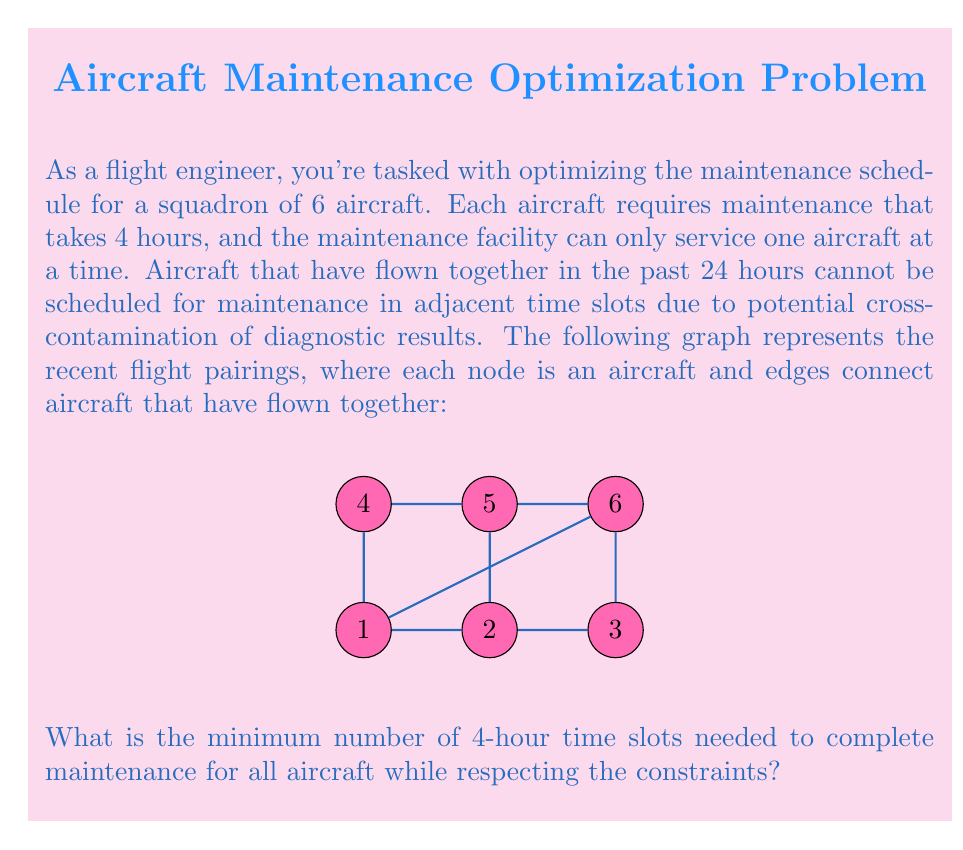Can you solve this math problem? To solve this problem, we can use graph coloring:

1) Each color represents a 4-hour time slot.
2) Adjacent nodes (aircraft that have flown together) must have different colors (time slots).
3) The minimum number of colors needed is the solution.

Step 1: Analyze the graph
- The graph is not complete, so we might need fewer colors than the total number of nodes.
- The maximum degree of any node is 4 (for nodes 1 and 5), which gives a lower bound of 5 colors needed.

Step 2: Apply a greedy coloring algorithm
- Start with node 1: Color 1
- Node 2: Color 2
- Node 3: Color 3
- Node 4: Color 2
- Node 5: Color 3
- Node 6: Color 1

Step 3: Verify the coloring
- No adjacent nodes have the same color.
- We used 3 colors in total.

Step 4: Check if this is optimal
- Given the structure of the graph, particularly the triangle formed by nodes 1, 2, and 3, we cannot use fewer than 3 colors.

Therefore, the minimum number of colors, and thus the minimum number of 4-hour time slots, is 3.

This solution allows for efficient use of the maintenance facility, as aircraft can be serviced in the following order: 1 and 6 (slot 1), 2 and 4 (slot 2), 3 and 5 (slot 3).
Answer: 3 time slots 